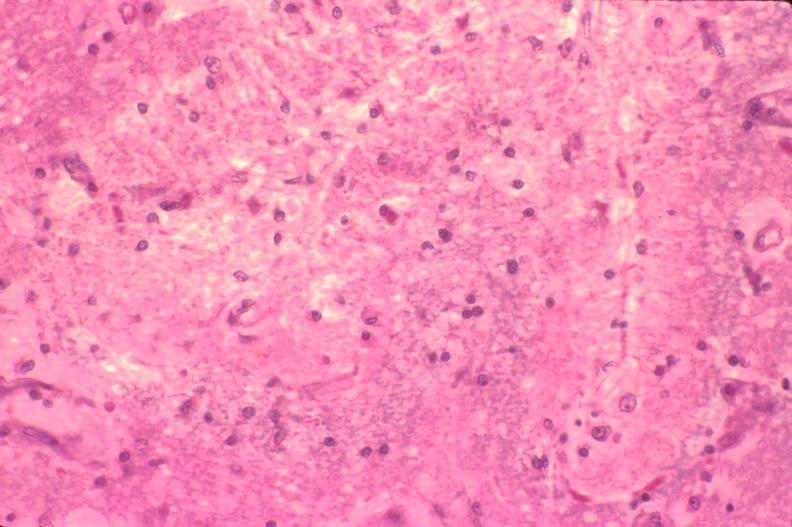s miliary tuberculosis present?
Answer the question using a single word or phrase. No 